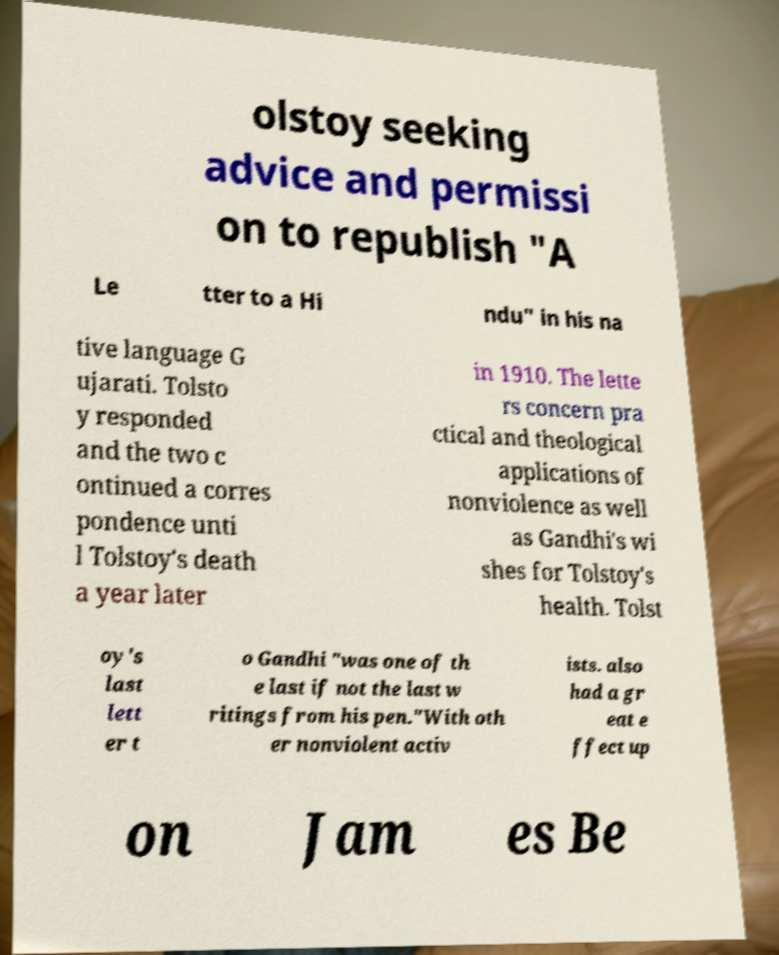Could you assist in decoding the text presented in this image and type it out clearly? olstoy seeking advice and permissi on to republish "A Le tter to a Hi ndu" in his na tive language G ujarati. Tolsto y responded and the two c ontinued a corres pondence unti l Tolstoy's death a year later in 1910. The lette rs concern pra ctical and theological applications of nonviolence as well as Gandhi's wi shes for Tolstoy's health. Tolst oy's last lett er t o Gandhi "was one of th e last if not the last w ritings from his pen."With oth er nonviolent activ ists. also had a gr eat e ffect up on Jam es Be 